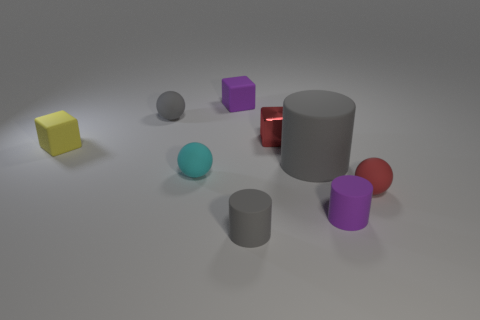Subtract all purple cylinders. How many cylinders are left? 2 Subtract all purple blocks. How many gray cylinders are left? 2 Subtract 1 balls. How many balls are left? 2 Add 1 tiny cyan cylinders. How many objects exist? 10 Subtract all gray blocks. Subtract all blue cylinders. How many blocks are left? 3 Subtract 0 brown balls. How many objects are left? 9 Subtract all cylinders. How many objects are left? 6 Subtract all tiny matte spheres. Subtract all tiny red metallic blocks. How many objects are left? 5 Add 5 red blocks. How many red blocks are left? 6 Add 1 gray balls. How many gray balls exist? 2 